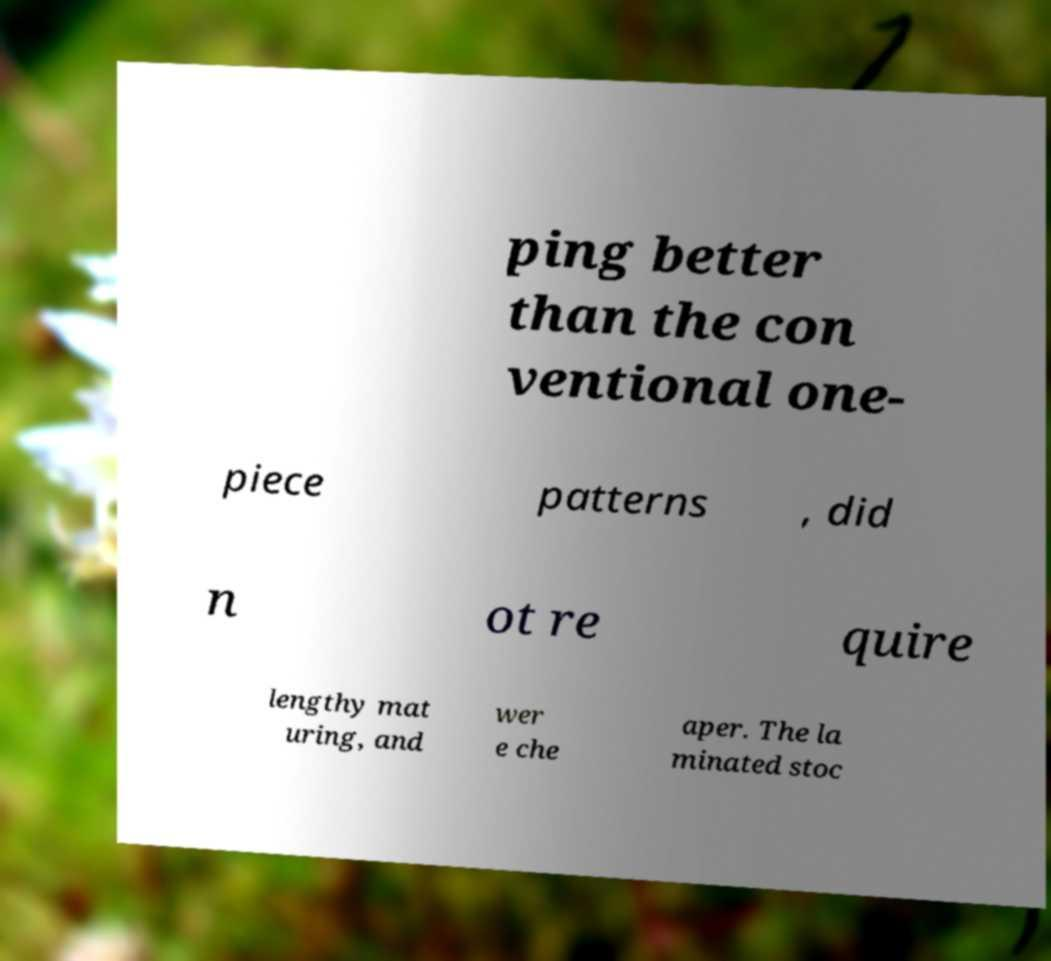Could you extract and type out the text from this image? ping better than the con ventional one- piece patterns , did n ot re quire lengthy mat uring, and wer e che aper. The la minated stoc 